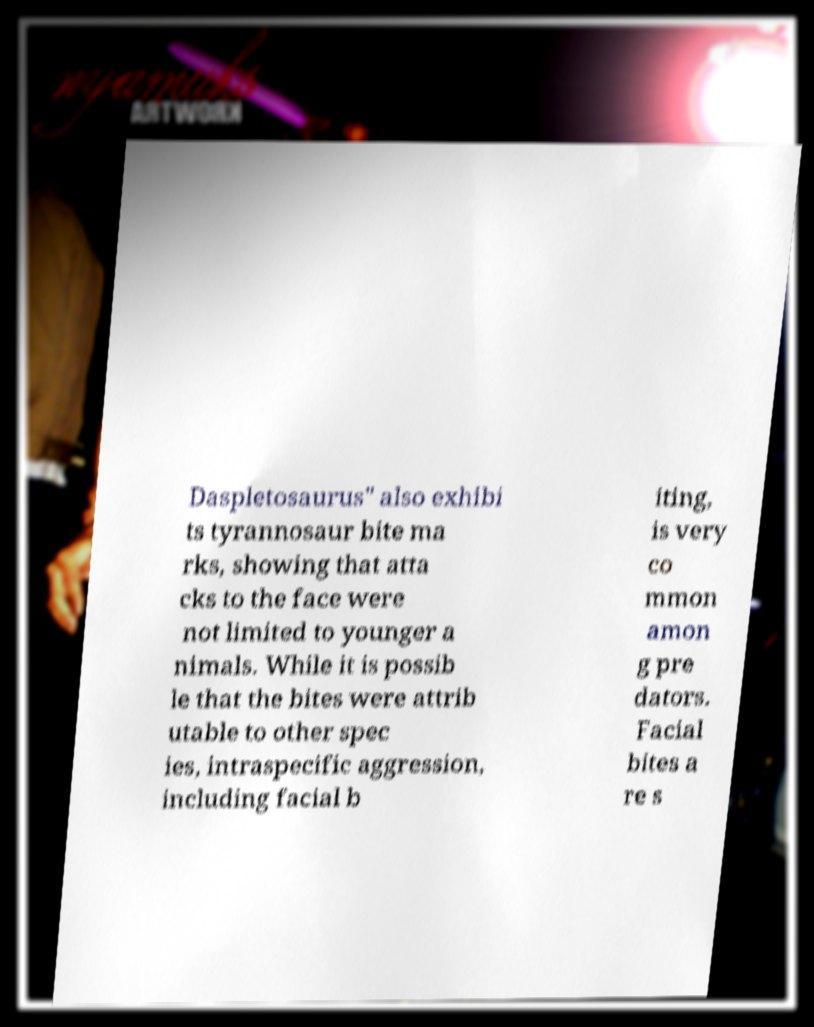Can you read and provide the text displayed in the image?This photo seems to have some interesting text. Can you extract and type it out for me? Daspletosaurus" also exhibi ts tyrannosaur bite ma rks, showing that atta cks to the face were not limited to younger a nimals. While it is possib le that the bites were attrib utable to other spec ies, intraspecific aggression, including facial b iting, is very co mmon amon g pre dators. Facial bites a re s 